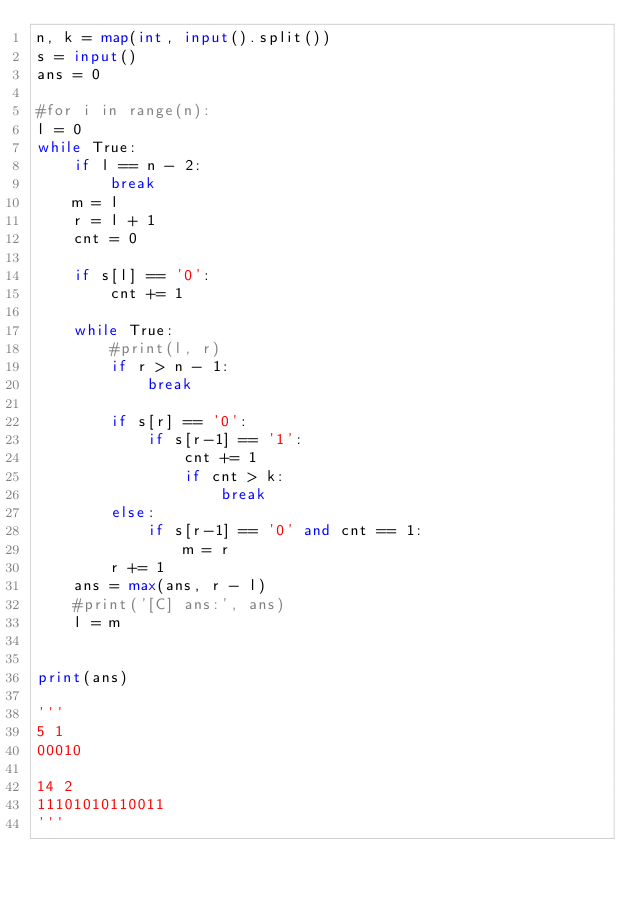Convert code to text. <code><loc_0><loc_0><loc_500><loc_500><_Python_>n, k = map(int, input().split())
s = input()
ans = 0

#for i in range(n):
l = 0
while True:
    if l == n - 2:
        break
    m = l
    r = l + 1
    cnt = 0

    if s[l] == '0':
        cnt += 1

    while True:
        #print(l, r)
        if r > n - 1:
            break

        if s[r] == '0':
            if s[r-1] == '1':
                cnt += 1
                if cnt > k:
                    break
        else:
            if s[r-1] == '0' and cnt == 1:
                m = r
        r += 1
    ans = max(ans, r - l)
    #print('[C] ans:', ans)
    l = m


print(ans)

'''
5 1
00010

14 2
11101010110011
'''
</code> 